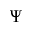Convert formula to latex. <formula><loc_0><loc_0><loc_500><loc_500>\Psi</formula> 